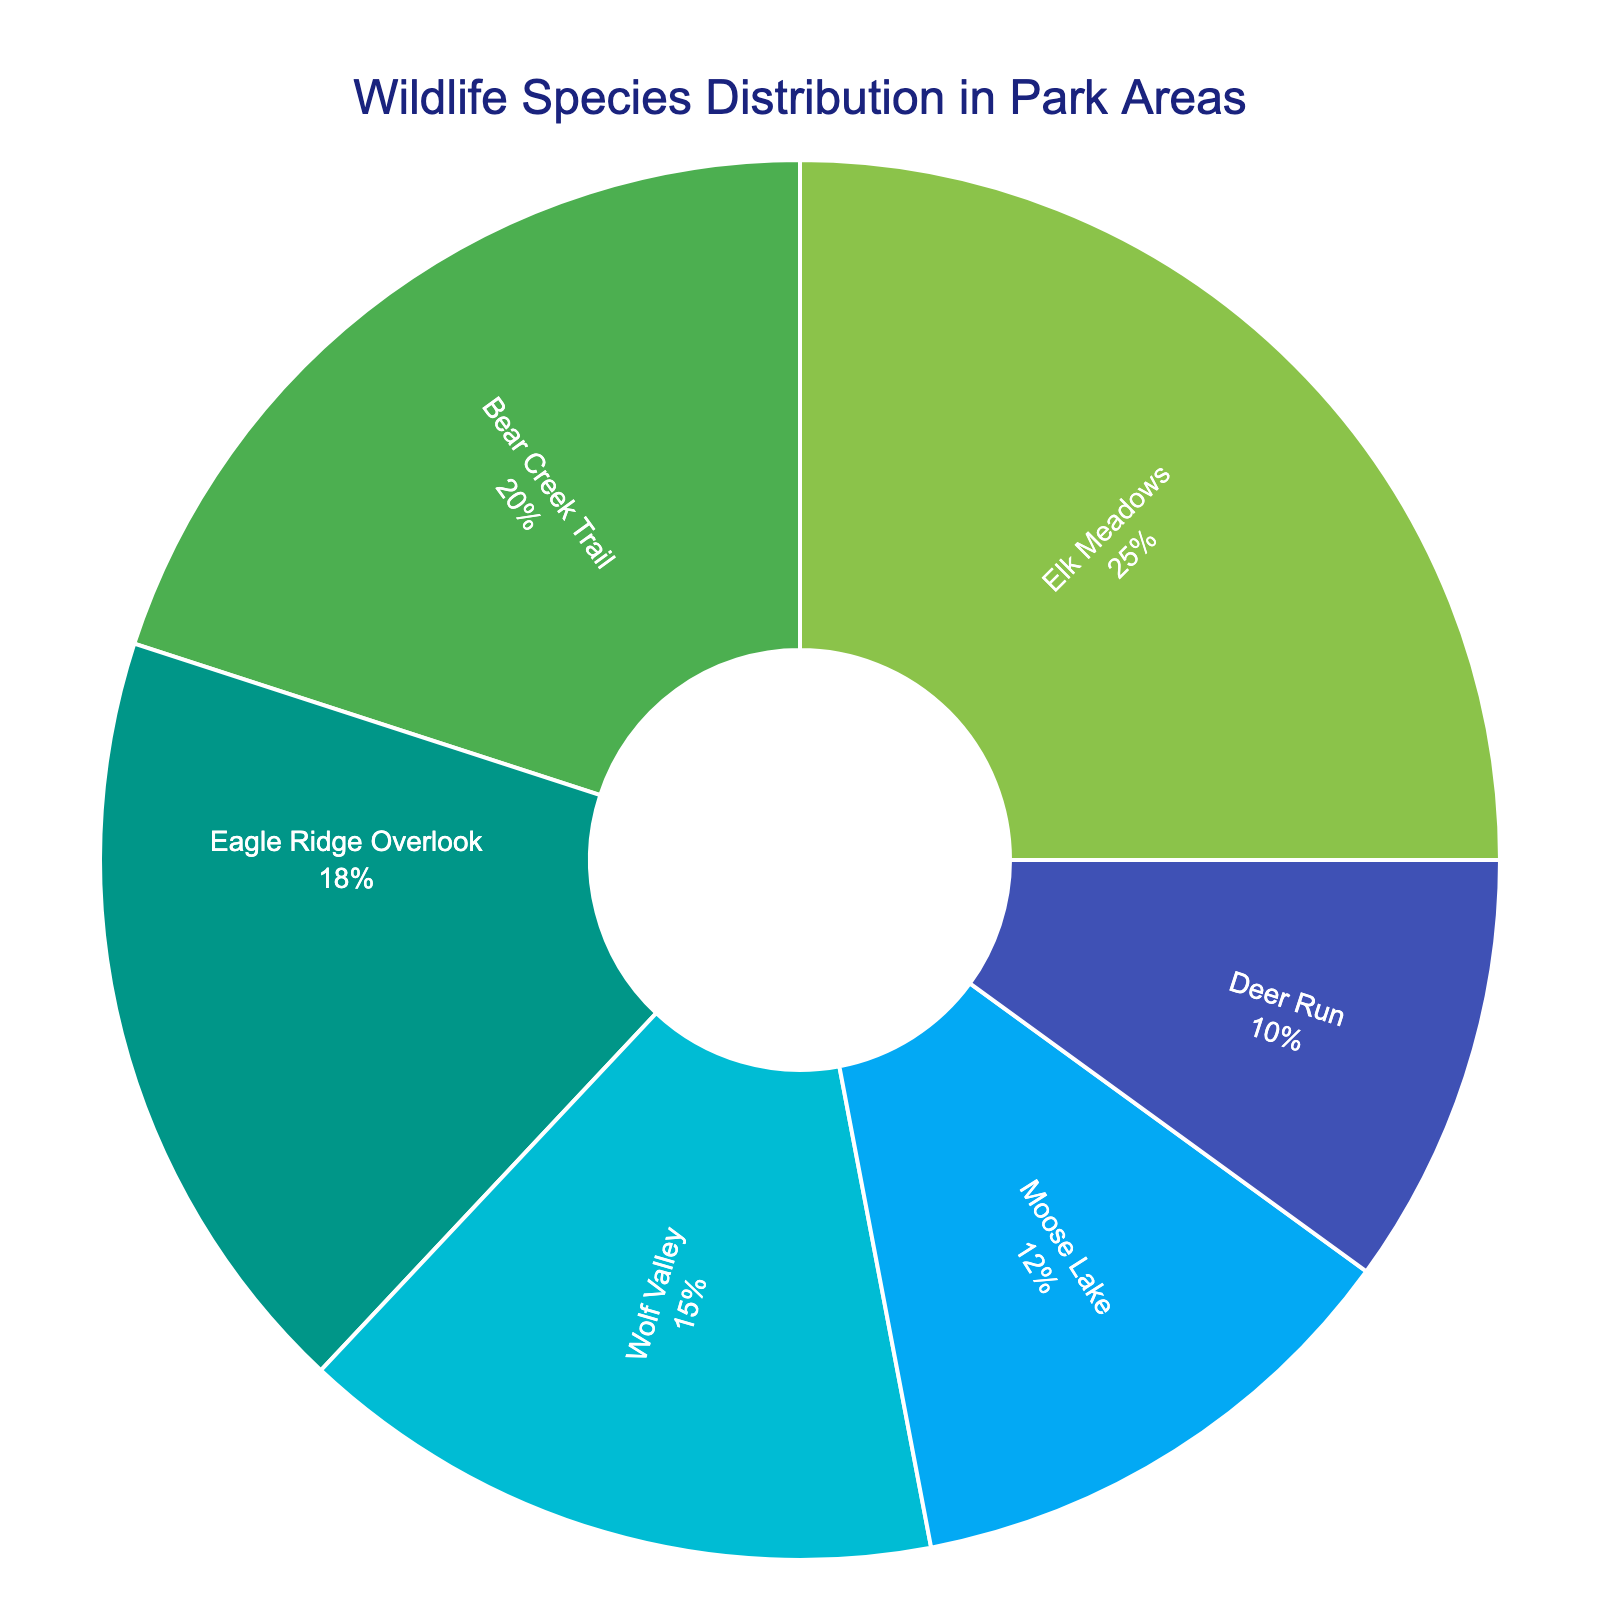Which area has the highest percentage of wildlife species? The area with the highest percentage of wildlife species is identified by the largest segment in the pie chart. In this case, Elk Meadows has the largest segment.
Answer: Elk Meadows What is the combined percentage of wildlife species spotted in Eagle Ridge Overlook and Deer Run? To find the combined percentage, add the percentages of Eagle Ridge Overlook and Deer Run. That is 18% + 10%.
Answer: 28% Is the percentage of wildlife species in Bear Creek Trail greater than in Moose Lake? Compare the percentage values of Bear Creek Trail (20%) and Moose Lake (12%). Since 20% is greater than 12%, Bear Creek Trail has a greater percentage.
Answer: Yes How much more percentage of wildlife species is there in Elk Meadows compared to Wolf Valley? Subtract the percentage of Wolf Valley from Elk Meadows. That is 25% - 15%.
Answer: 10% Which two areas combined have a percentage equivalent to Elk Meadows' percentage? Find two areas whose percentages sum to Elk Meadows' 25%. Moose Lake (12%) and Deer Run (10%) together are 22%, but Bear Creek Trail (20%) and Deer Run (10%) together make 30%, which is closer. No combination exactly equals 25%; however, would be closest to 25%.
Answer: No exact combination Rank the areas from highest to lowest according to the percentage of wildlife species spotted. List the areas in descending order of their percentages: Elk Meadows (25%), Bear Creek Trail (20%), Eagle Ridge Overlook (18%), Wolf Valley (15%), Moose Lake (12%), Deer Run (10%).
Answer: Elk Meadows, Bear Creek Trail, Eagle Ridge Overlook, Wolf Valley, Moose Lake, Deer Run What is the percentage difference between Eagle Ridge Overlook and Bear Creek Trail? Subtract the percentage of Eagle Ridge Overlook from Bear Creek Trail. That is 20% - 18%.
Answer: 2% What percentage of the total wildlife species is found in Wolf Valley and Moose Lake combined? Add the percentages of Wolf Valley and Moose Lake. That is 15% + 12%.
Answer: 27% Is the percentage of wildlife species in Eagle Ridge Overlook (18%) closer to Bear Creek Trail (20%) or Moose Lake (12%)? Compare the absolute differences: 20% - 18% = 2%, and 18% - 12% = 6%. The difference to Bear Creek Trail is smaller.
Answer: Bear Creek Trail 